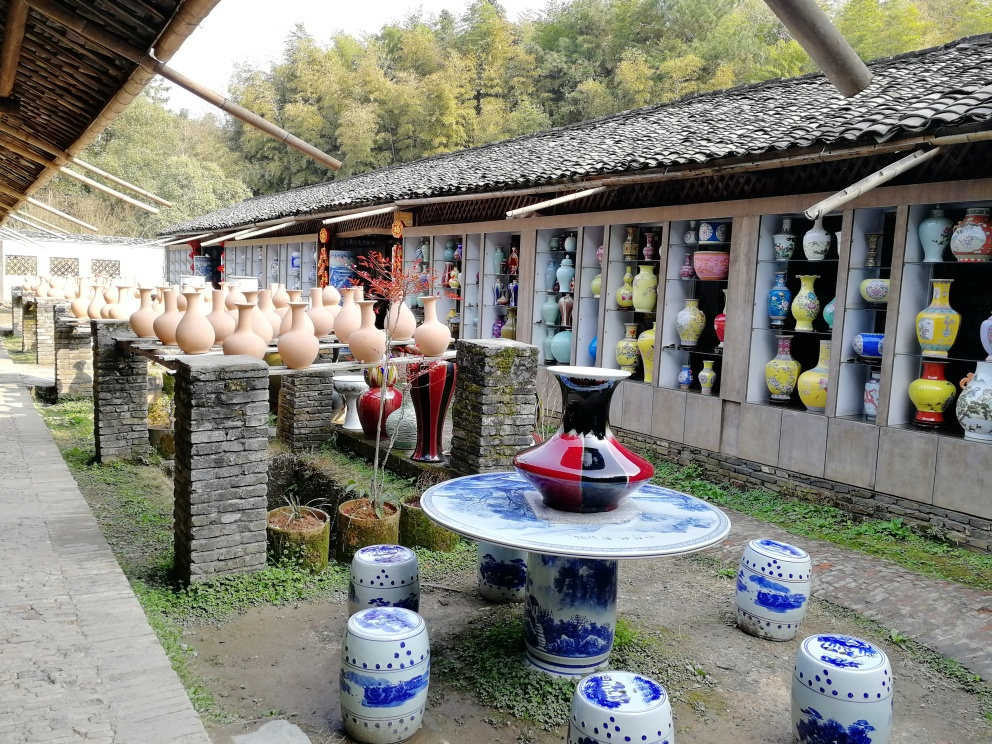What does the presence of these ceramics imply about the local culture? The abundance and variety of ceramics in the image imply that the local culture has a deep connection to the art of pottery and porcelain production. Such expertise and diversity suggest a community that not only has a history of ceramic craftsmanship but also values this tradition as a formative aspect of its cultural identity. The showcased items range from utilitarian wares to highly decorative arts, indicating that ceramics play both functional and aesthetic roles in daily life. It's likely that local artisans have passed down their skills through generations, and this setting serves as both a preservation and celebration of their heritage. 